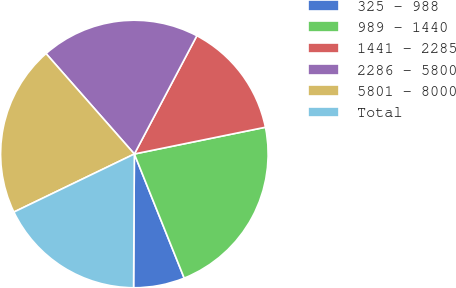Convert chart to OTSL. <chart><loc_0><loc_0><loc_500><loc_500><pie_chart><fcel>325 - 988<fcel>989 - 1440<fcel>1441 - 2285<fcel>2286 - 5800<fcel>5801 - 8000<fcel>Total<nl><fcel>6.17%<fcel>22.13%<fcel>14.06%<fcel>19.22%<fcel>20.67%<fcel>17.76%<nl></chart> 